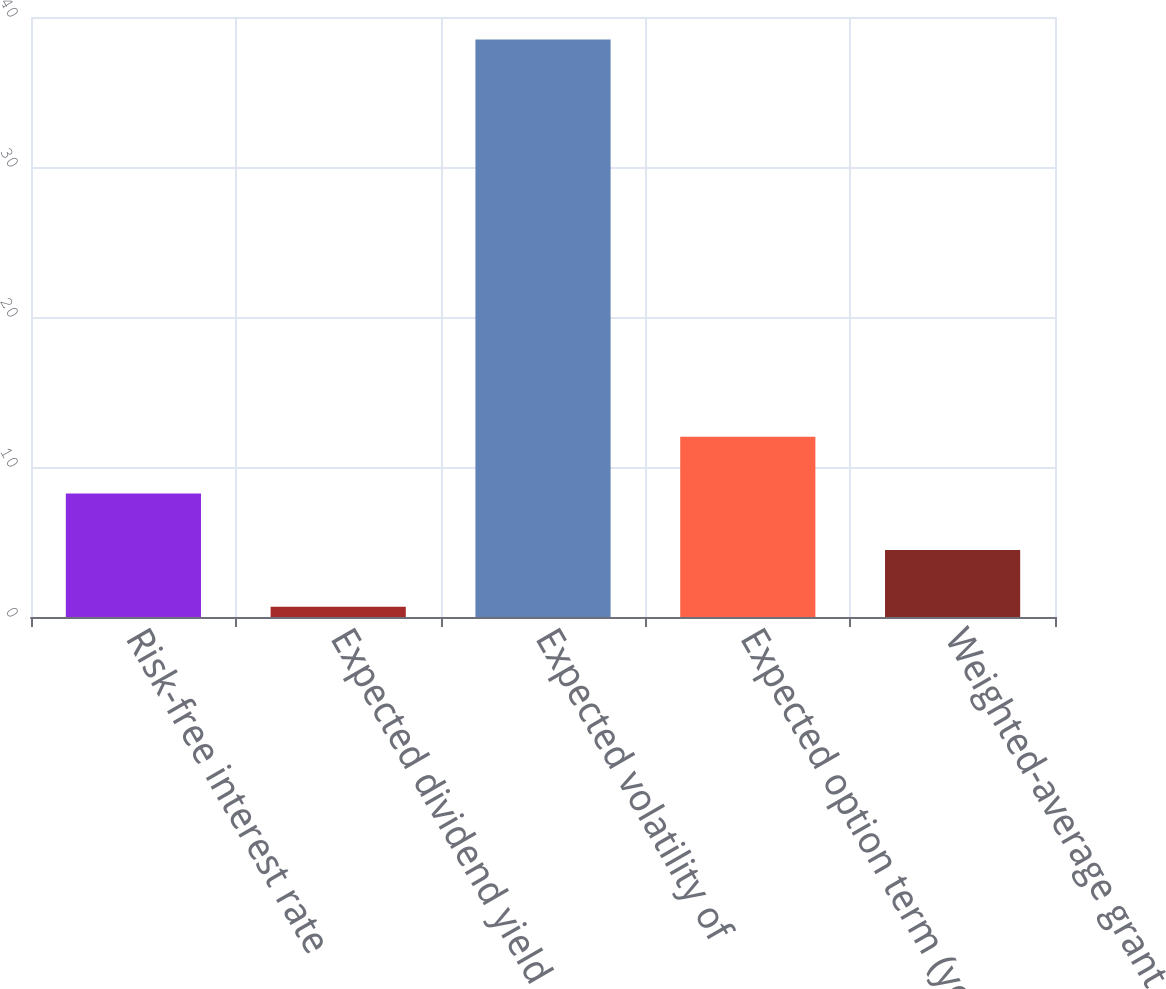Convert chart. <chart><loc_0><loc_0><loc_500><loc_500><bar_chart><fcel>Risk-free interest rate<fcel>Expected dividend yield<fcel>Expected volatility of<fcel>Expected option term (years)<fcel>Weighted-average grant date<nl><fcel>8.24<fcel>0.68<fcel>38.5<fcel>12.02<fcel>4.46<nl></chart> 